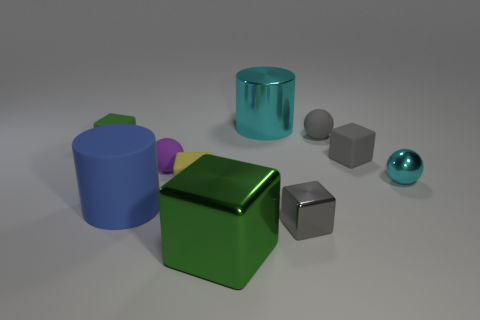Subtract all rubber blocks. How many blocks are left? 2 Subtract all yellow cylinders. How many green cubes are left? 2 Subtract 1 balls. How many balls are left? 2 Subtract all blue cylinders. How many cylinders are left? 1 Subtract all cylinders. How many objects are left? 8 Add 7 big shiny cylinders. How many big shiny cylinders are left? 8 Add 8 green matte things. How many green matte things exist? 9 Subtract 0 cyan blocks. How many objects are left? 10 Subtract all yellow cubes. Subtract all green cylinders. How many cubes are left? 4 Subtract all tiny matte blocks. Subtract all big purple cylinders. How many objects are left? 7 